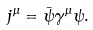Convert formula to latex. <formula><loc_0><loc_0><loc_500><loc_500>j ^ { \mu } = \bar { \psi } \gamma ^ { \mu } \psi .</formula> 